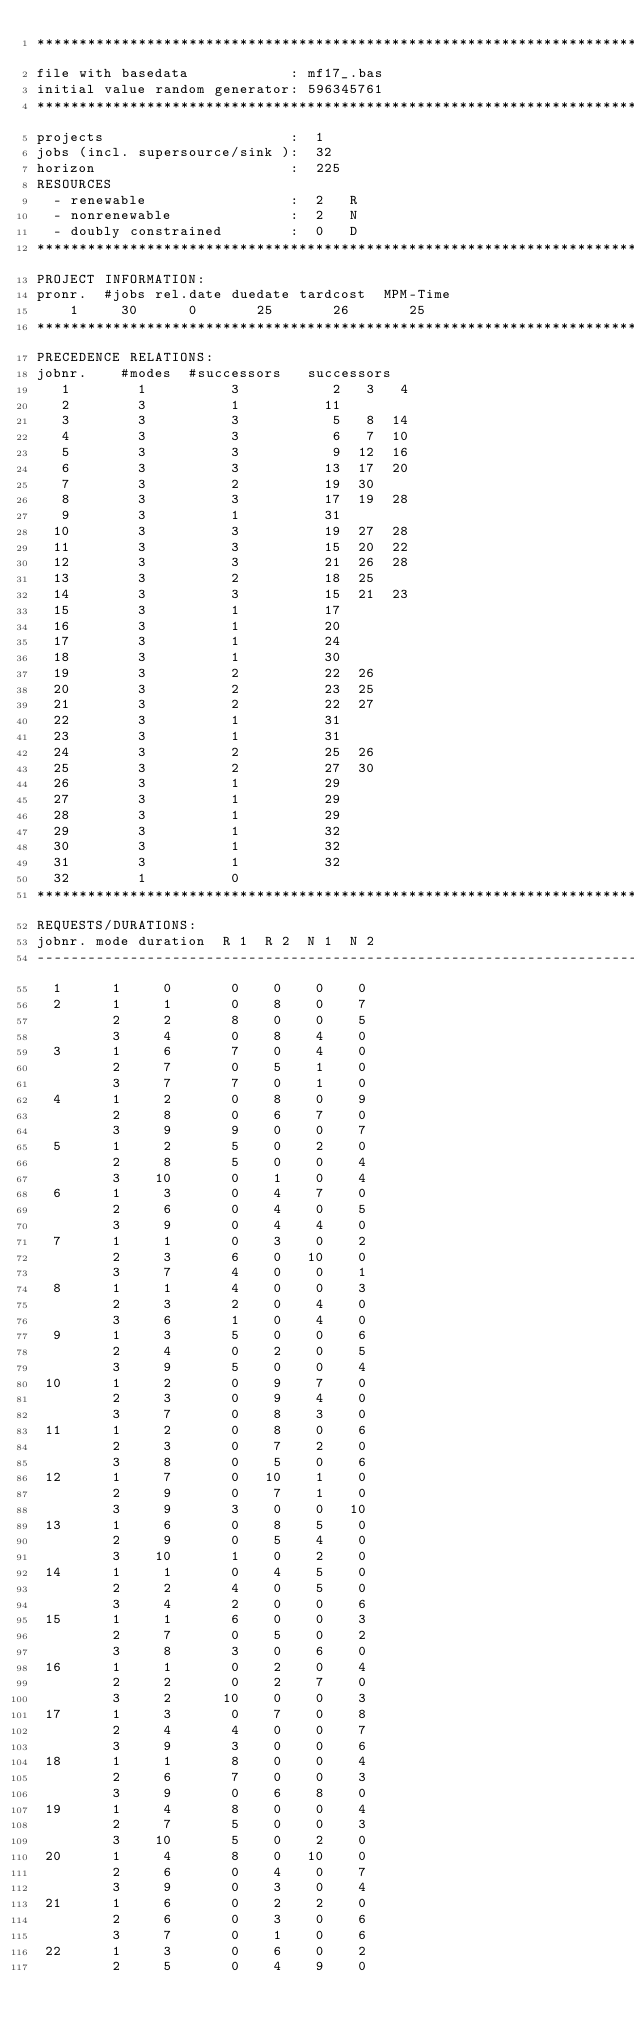Convert code to text. <code><loc_0><loc_0><loc_500><loc_500><_ObjectiveC_>************************************************************************
file with basedata            : mf17_.bas
initial value random generator: 596345761
************************************************************************
projects                      :  1
jobs (incl. supersource/sink ):  32
horizon                       :  225
RESOURCES
  - renewable                 :  2   R
  - nonrenewable              :  2   N
  - doubly constrained        :  0   D
************************************************************************
PROJECT INFORMATION:
pronr.  #jobs rel.date duedate tardcost  MPM-Time
    1     30      0       25       26       25
************************************************************************
PRECEDENCE RELATIONS:
jobnr.    #modes  #successors   successors
   1        1          3           2   3   4
   2        3          1          11
   3        3          3           5   8  14
   4        3          3           6   7  10
   5        3          3           9  12  16
   6        3          3          13  17  20
   7        3          2          19  30
   8        3          3          17  19  28
   9        3          1          31
  10        3          3          19  27  28
  11        3          3          15  20  22
  12        3          3          21  26  28
  13        3          2          18  25
  14        3          3          15  21  23
  15        3          1          17
  16        3          1          20
  17        3          1          24
  18        3          1          30
  19        3          2          22  26
  20        3          2          23  25
  21        3          2          22  27
  22        3          1          31
  23        3          1          31
  24        3          2          25  26
  25        3          2          27  30
  26        3          1          29
  27        3          1          29
  28        3          1          29
  29        3          1          32
  30        3          1          32
  31        3          1          32
  32        1          0        
************************************************************************
REQUESTS/DURATIONS:
jobnr. mode duration  R 1  R 2  N 1  N 2
------------------------------------------------------------------------
  1      1     0       0    0    0    0
  2      1     1       0    8    0    7
         2     2       8    0    0    5
         3     4       0    8    4    0
  3      1     6       7    0    4    0
         2     7       0    5    1    0
         3     7       7    0    1    0
  4      1     2       0    8    0    9
         2     8       0    6    7    0
         3     9       9    0    0    7
  5      1     2       5    0    2    0
         2     8       5    0    0    4
         3    10       0    1    0    4
  6      1     3       0    4    7    0
         2     6       0    4    0    5
         3     9       0    4    4    0
  7      1     1       0    3    0    2
         2     3       6    0   10    0
         3     7       4    0    0    1
  8      1     1       4    0    0    3
         2     3       2    0    4    0
         3     6       1    0    4    0
  9      1     3       5    0    0    6
         2     4       0    2    0    5
         3     9       5    0    0    4
 10      1     2       0    9    7    0
         2     3       0    9    4    0
         3     7       0    8    3    0
 11      1     2       0    8    0    6
         2     3       0    7    2    0
         3     8       0    5    0    6
 12      1     7       0   10    1    0
         2     9       0    7    1    0
         3     9       3    0    0   10
 13      1     6       0    8    5    0
         2     9       0    5    4    0
         3    10       1    0    2    0
 14      1     1       0    4    5    0
         2     2       4    0    5    0
         3     4       2    0    0    6
 15      1     1       6    0    0    3
         2     7       0    5    0    2
         3     8       3    0    6    0
 16      1     1       0    2    0    4
         2     2       0    2    7    0
         3     2      10    0    0    3
 17      1     3       0    7    0    8
         2     4       4    0    0    7
         3     9       3    0    0    6
 18      1     1       8    0    0    4
         2     6       7    0    0    3
         3     9       0    6    8    0
 19      1     4       8    0    0    4
         2     7       5    0    0    3
         3    10       5    0    2    0
 20      1     4       8    0   10    0
         2     6       0    4    0    7
         3     9       0    3    0    4
 21      1     6       0    2    2    0
         2     6       0    3    0    6
         3     7       0    1    0    6
 22      1     3       0    6    0    2
         2     5       0    4    9    0</code> 